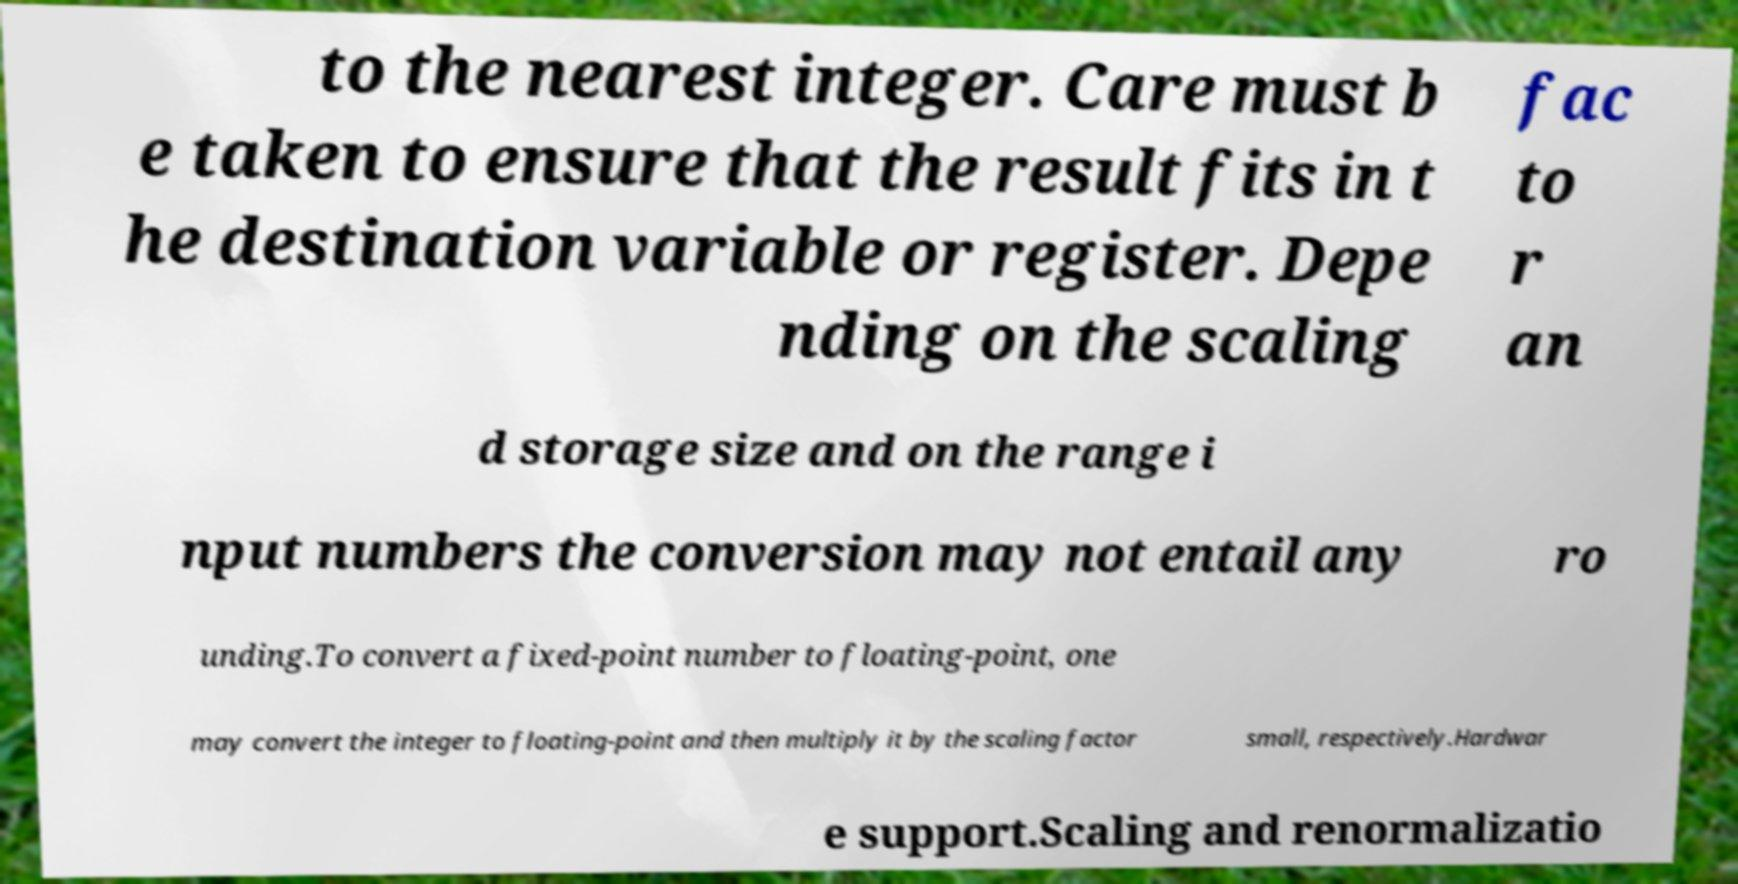Could you extract and type out the text from this image? to the nearest integer. Care must b e taken to ensure that the result fits in t he destination variable or register. Depe nding on the scaling fac to r an d storage size and on the range i nput numbers the conversion may not entail any ro unding.To convert a fixed-point number to floating-point, one may convert the integer to floating-point and then multiply it by the scaling factor small, respectively.Hardwar e support.Scaling and renormalizatio 